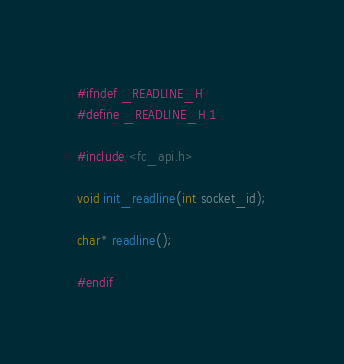Convert code to text. <code><loc_0><loc_0><loc_500><loc_500><_C_>#ifndef _READLINE_H 
#define _READLINE_H 1

#include <fc_api.h>

void init_readline(int socket_id);

char* readline();

#endif
</code> 